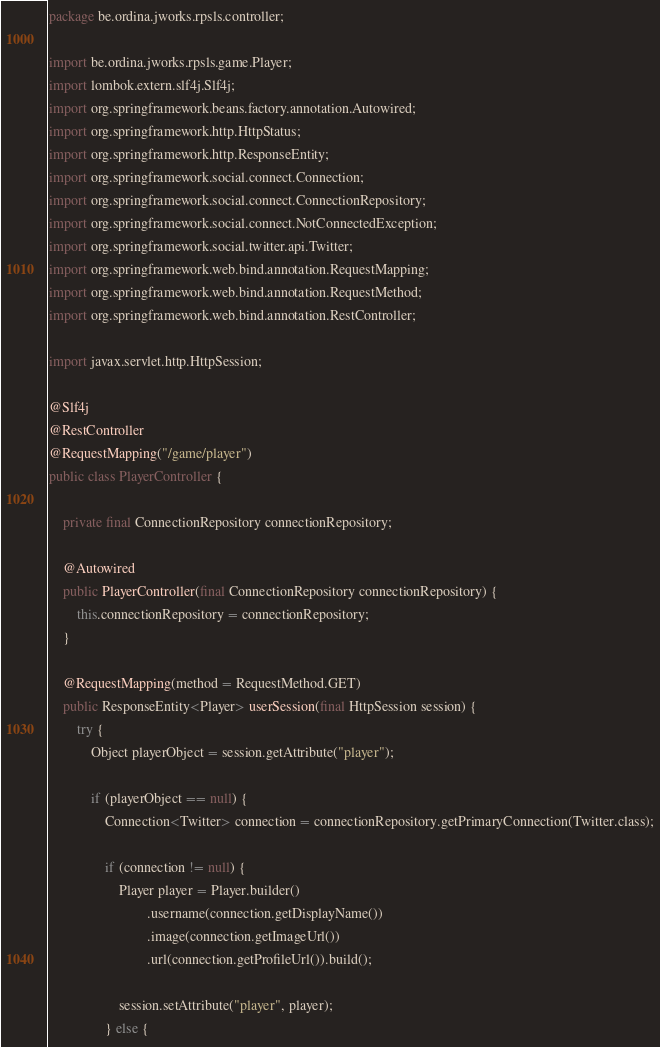Convert code to text. <code><loc_0><loc_0><loc_500><loc_500><_Java_>package be.ordina.jworks.rpsls.controller;

import be.ordina.jworks.rpsls.game.Player;
import lombok.extern.slf4j.Slf4j;
import org.springframework.beans.factory.annotation.Autowired;
import org.springframework.http.HttpStatus;
import org.springframework.http.ResponseEntity;
import org.springframework.social.connect.Connection;
import org.springframework.social.connect.ConnectionRepository;
import org.springframework.social.connect.NotConnectedException;
import org.springframework.social.twitter.api.Twitter;
import org.springframework.web.bind.annotation.RequestMapping;
import org.springframework.web.bind.annotation.RequestMethod;
import org.springframework.web.bind.annotation.RestController;

import javax.servlet.http.HttpSession;

@Slf4j
@RestController
@RequestMapping("/game/player")
public class PlayerController {

    private final ConnectionRepository connectionRepository;

    @Autowired
    public PlayerController(final ConnectionRepository connectionRepository) {
        this.connectionRepository = connectionRepository;
    }

    @RequestMapping(method = RequestMethod.GET)
    public ResponseEntity<Player> userSession(final HttpSession session) {
        try {
            Object playerObject = session.getAttribute("player");

            if (playerObject == null) {
                Connection<Twitter> connection = connectionRepository.getPrimaryConnection(Twitter.class);

                if (connection != null) {
                    Player player = Player.builder()
                            .username(connection.getDisplayName())
                            .image(connection.getImageUrl())
                            .url(connection.getProfileUrl()).build();

                    session.setAttribute("player", player);
                } else {</code> 